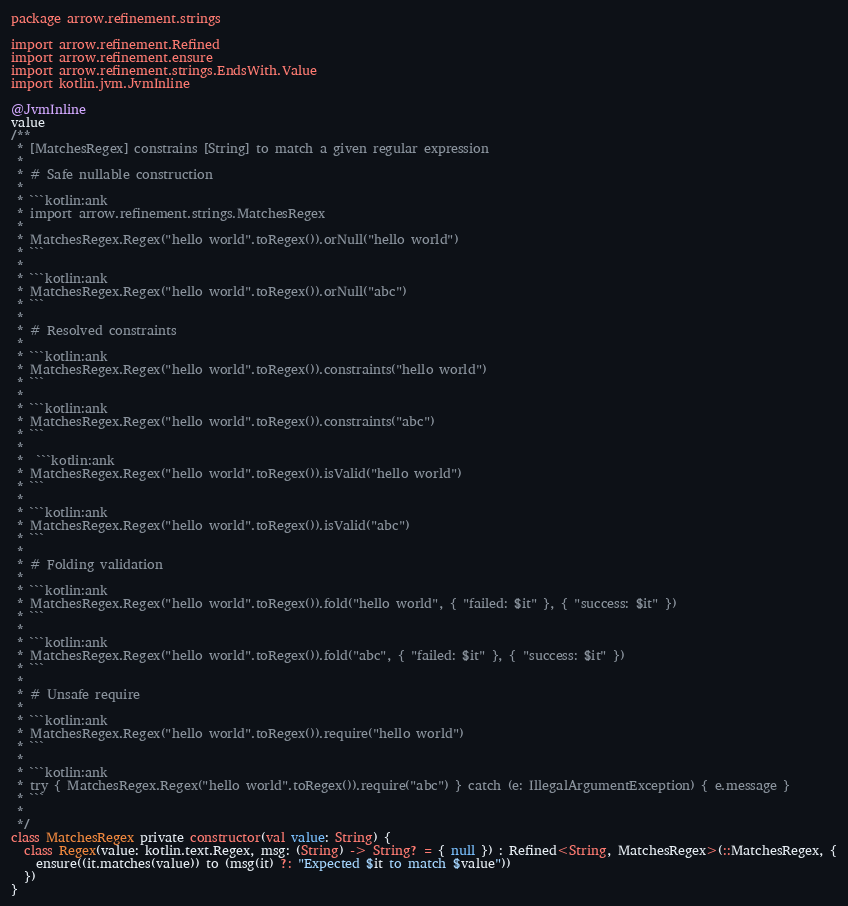Convert code to text. <code><loc_0><loc_0><loc_500><loc_500><_Kotlin_>package arrow.refinement.strings

import arrow.refinement.Refined
import arrow.refinement.ensure
import arrow.refinement.strings.EndsWith.Value
import kotlin.jvm.JvmInline

@JvmInline
value
/**
 * [MatchesRegex] constrains [String] to match a given regular expression
 *
 * # Safe nullable construction
 *
 * ```kotlin:ank
 * import arrow.refinement.strings.MatchesRegex
 *
 * MatchesRegex.Regex("hello world".toRegex()).orNull("hello world")
 * ```
 *
 * ```kotlin:ank
 * MatchesRegex.Regex("hello world".toRegex()).orNull("abc")
 * ```
 *
 * # Resolved constraints
 *
 * ```kotlin:ank
 * MatchesRegex.Regex("hello world".toRegex()).constraints("hello world")
 * ```
 *
 * ```kotlin:ank
 * MatchesRegex.Regex("hello world".toRegex()).constraints("abc")
 * ```
 *
 *  ```kotlin:ank
 * MatchesRegex.Regex("hello world".toRegex()).isValid("hello world")
 * ```
 *
 * ```kotlin:ank
 * MatchesRegex.Regex("hello world".toRegex()).isValid("abc")
 * ```
 *
 * # Folding validation
 *
 * ```kotlin:ank
 * MatchesRegex.Regex("hello world".toRegex()).fold("hello world", { "failed: $it" }, { "success: $it" })
 * ```
 *
 * ```kotlin:ank
 * MatchesRegex.Regex("hello world".toRegex()).fold("abc", { "failed: $it" }, { "success: $it" })
 * ```
 *
 * # Unsafe require
 *
 * ```kotlin:ank
 * MatchesRegex.Regex("hello world".toRegex()).require("hello world")
 * ```
 *
 * ```kotlin:ank
 * try { MatchesRegex.Regex("hello world".toRegex()).require("abc") } catch (e: IllegalArgumentException) { e.message }
 * ```
 *
 */
class MatchesRegex private constructor(val value: String) {
  class Regex(value: kotlin.text.Regex, msg: (String) -> String? = { null }) : Refined<String, MatchesRegex>(::MatchesRegex, {
    ensure((it.matches(value)) to (msg(it) ?: "Expected $it to match $value"))
  })
}</code> 